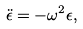Convert formula to latex. <formula><loc_0><loc_0><loc_500><loc_500>\ddot { \epsilon } = - \omega ^ { 2 } \epsilon ,</formula> 